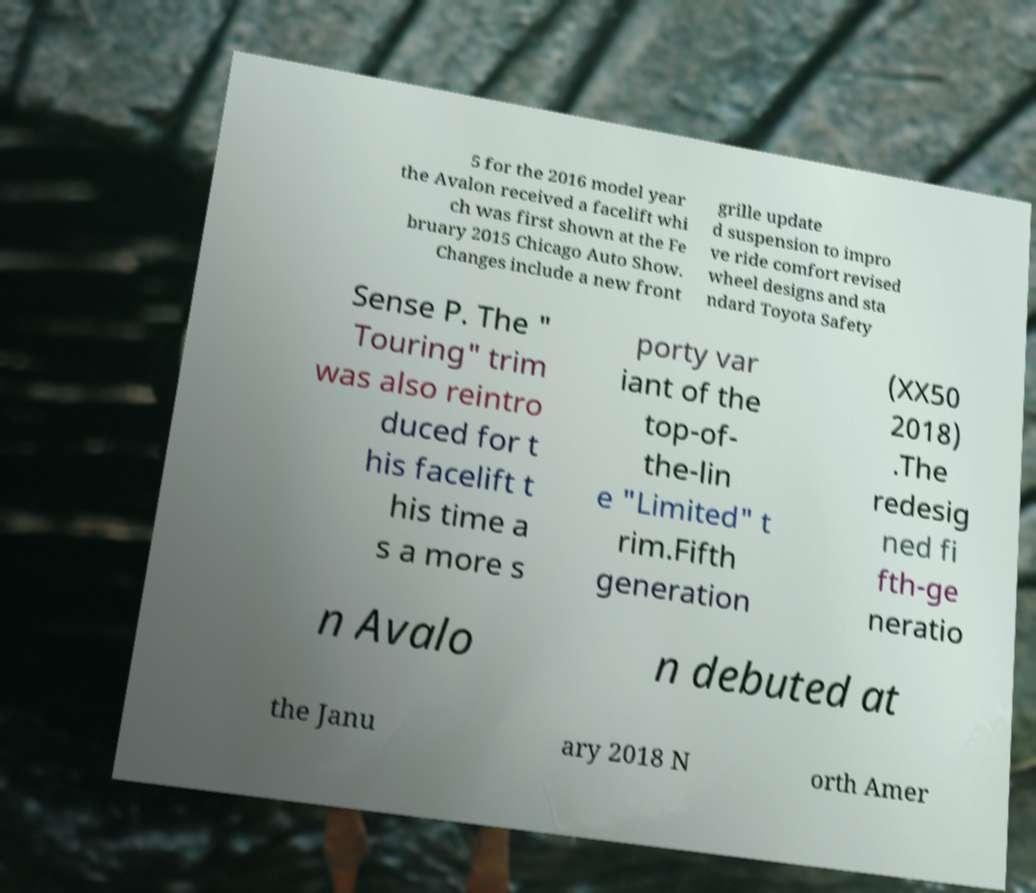What messages or text are displayed in this image? I need them in a readable, typed format. 5 for the 2016 model year the Avalon received a facelift whi ch was first shown at the Fe bruary 2015 Chicago Auto Show. Changes include a new front grille update d suspension to impro ve ride comfort revised wheel designs and sta ndard Toyota Safety Sense P. The " Touring" trim was also reintro duced for t his facelift t his time a s a more s porty var iant of the top-of- the-lin e "Limited" t rim.Fifth generation (XX50 2018) .The redesig ned fi fth-ge neratio n Avalo n debuted at the Janu ary 2018 N orth Amer 